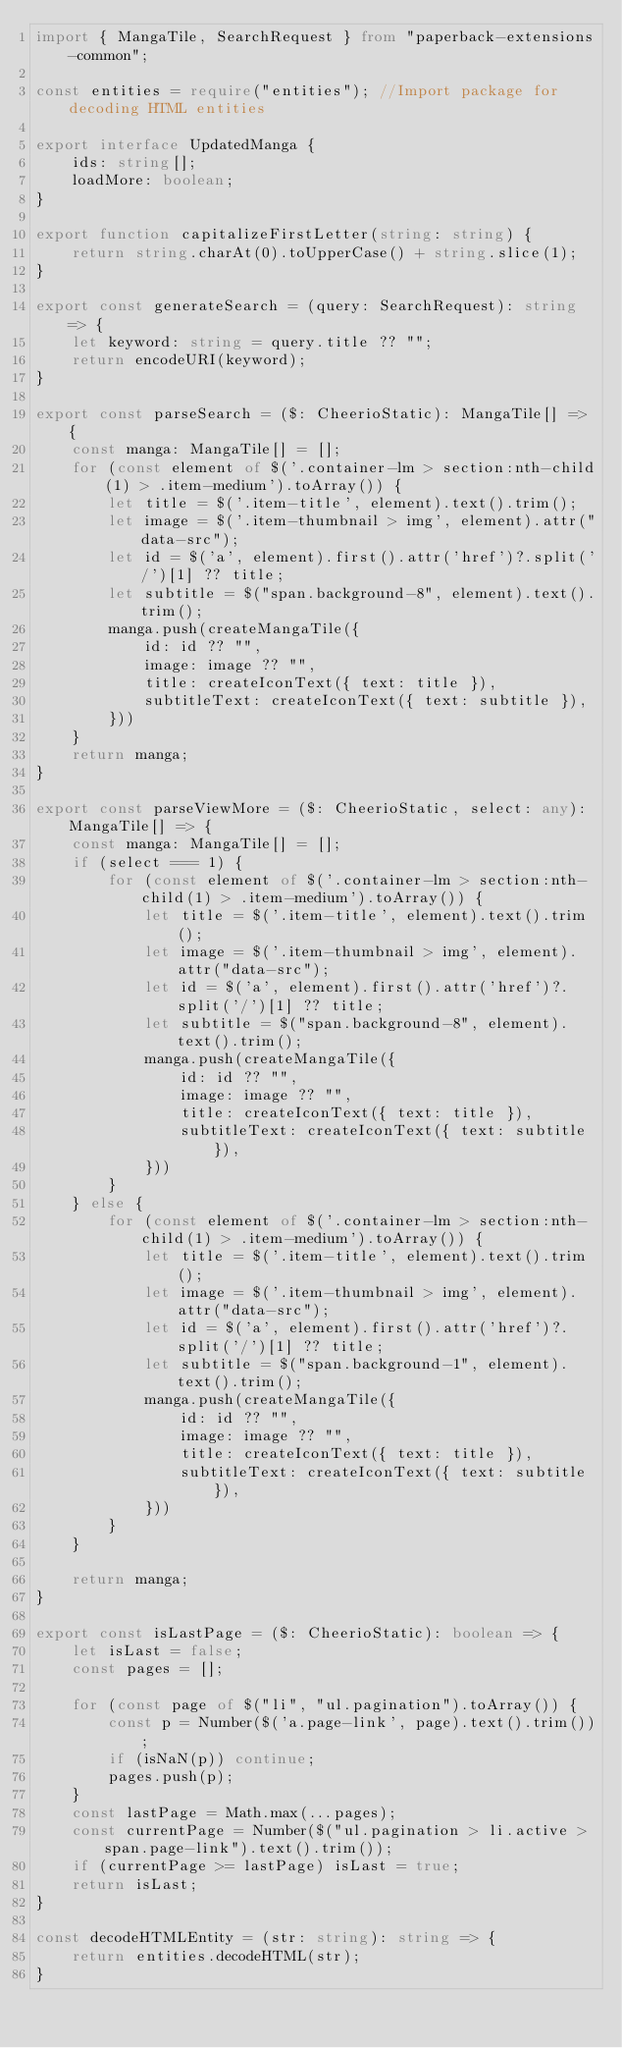<code> <loc_0><loc_0><loc_500><loc_500><_TypeScript_>import { MangaTile, SearchRequest } from "paperback-extensions-common";

const entities = require("entities"); //Import package for decoding HTML entities

export interface UpdatedManga {
    ids: string[];
    loadMore: boolean;
}

export function capitalizeFirstLetter(string: string) {
    return string.charAt(0).toUpperCase() + string.slice(1);
}

export const generateSearch = (query: SearchRequest): string => {
    let keyword: string = query.title ?? "";
    return encodeURI(keyword);
}

export const parseSearch = ($: CheerioStatic): MangaTile[] => {
    const manga: MangaTile[] = [];
    for (const element of $('.container-lm > section:nth-child(1) > .item-medium').toArray()) {
        let title = $('.item-title', element).text().trim();
        let image = $('.item-thumbnail > img', element).attr("data-src");
        let id = $('a', element).first().attr('href')?.split('/')[1] ?? title;
        let subtitle = $("span.background-8", element).text().trim();
        manga.push(createMangaTile({
            id: id ?? "",
            image: image ?? "",
            title: createIconText({ text: title }),
            subtitleText: createIconText({ text: subtitle }),
        }))
    }
    return manga;
}

export const parseViewMore = ($: CheerioStatic, select: any): MangaTile[] => {
    const manga: MangaTile[] = [];
    if (select === 1) {
        for (const element of $('.container-lm > section:nth-child(1) > .item-medium').toArray()) {
            let title = $('.item-title', element).text().trim();
            let image = $('.item-thumbnail > img', element).attr("data-src");
            let id = $('a', element).first().attr('href')?.split('/')[1] ?? title;
            let subtitle = $("span.background-8", element).text().trim();
            manga.push(createMangaTile({
                id: id ?? "",
                image: image ?? "",
                title: createIconText({ text: title }),
                subtitleText: createIconText({ text: subtitle }),
            }))
        }
    } else {
        for (const element of $('.container-lm > section:nth-child(1) > .item-medium').toArray()) {
            let title = $('.item-title', element).text().trim();
            let image = $('.item-thumbnail > img', element).attr("data-src");
            let id = $('a', element).first().attr('href')?.split('/')[1] ?? title;
            let subtitle = $("span.background-1", element).text().trim();
            manga.push(createMangaTile({
                id: id ?? "",
                image: image ?? "",
                title: createIconText({ text: title }),
                subtitleText: createIconText({ text: subtitle }),
            }))
        }
    }

    return manga;
}

export const isLastPage = ($: CheerioStatic): boolean => {
    let isLast = false;
    const pages = [];

    for (const page of $("li", "ul.pagination").toArray()) {
        const p = Number($('a.page-link', page).text().trim());
        if (isNaN(p)) continue;
        pages.push(p);
    }
    const lastPage = Math.max(...pages);
    const currentPage = Number($("ul.pagination > li.active > span.page-link").text().trim());
    if (currentPage >= lastPage) isLast = true;
    return isLast;
}

const decodeHTMLEntity = (str: string): string => {
    return entities.decodeHTML(str);
}
</code> 